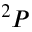<formula> <loc_0><loc_0><loc_500><loc_500>^ { 2 } P</formula> 